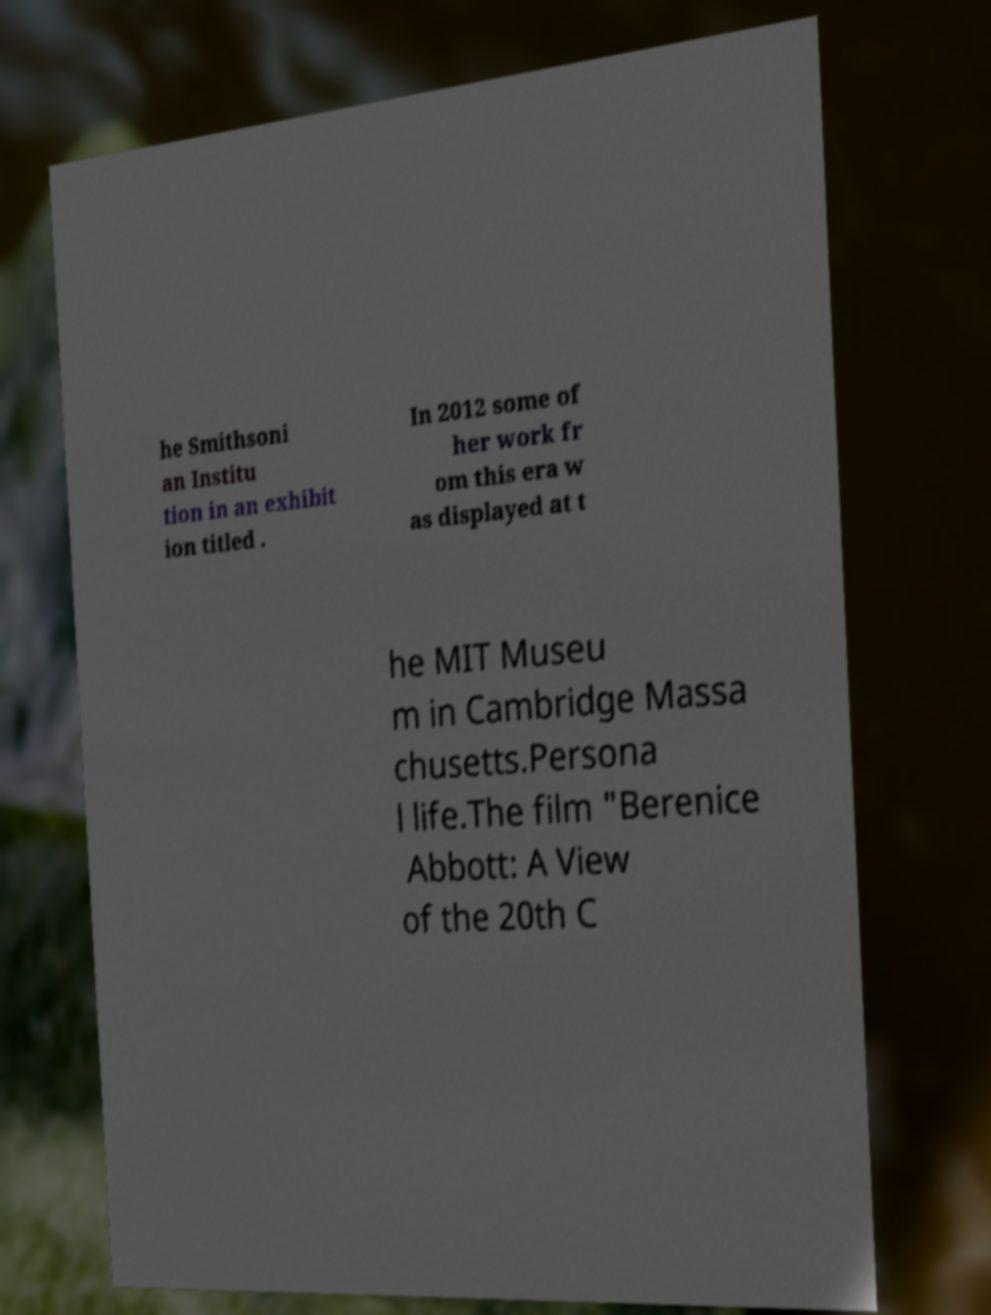I need the written content from this picture converted into text. Can you do that? he Smithsoni an Institu tion in an exhibit ion titled . In 2012 some of her work fr om this era w as displayed at t he MIT Museu m in Cambridge Massa chusetts.Persona l life.The film "Berenice Abbott: A View of the 20th C 